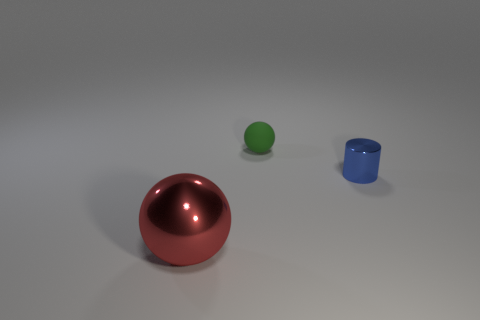Are there any other things that have the same shape as the tiny blue shiny object?
Your answer should be very brief. No. Are there fewer red objects on the right side of the rubber object than small balls that are right of the small blue metallic cylinder?
Offer a terse response. No. What number of other things are there of the same shape as the blue thing?
Your answer should be compact. 0. How big is the thing that is in front of the metal thing that is to the right of the sphere that is behind the big red object?
Keep it short and to the point. Large. How many brown objects are small shiny cylinders or large things?
Your answer should be very brief. 0. What shape is the small object that is right of the ball to the right of the large metallic object?
Provide a succinct answer. Cylinder. Does the sphere behind the small shiny thing have the same size as the shiny thing in front of the metallic cylinder?
Give a very brief answer. No. Is there a tiny blue object that has the same material as the small blue cylinder?
Offer a terse response. No. Are there any small spheres left of the shiny object that is on the left side of the shiny thing that is behind the metallic ball?
Keep it short and to the point. No. Are there any large things in front of the cylinder?
Ensure brevity in your answer.  Yes. 